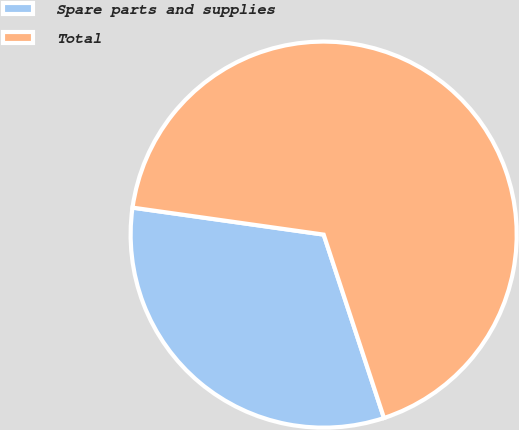Convert chart. <chart><loc_0><loc_0><loc_500><loc_500><pie_chart><fcel>Spare parts and supplies<fcel>Total<nl><fcel>32.29%<fcel>67.71%<nl></chart> 